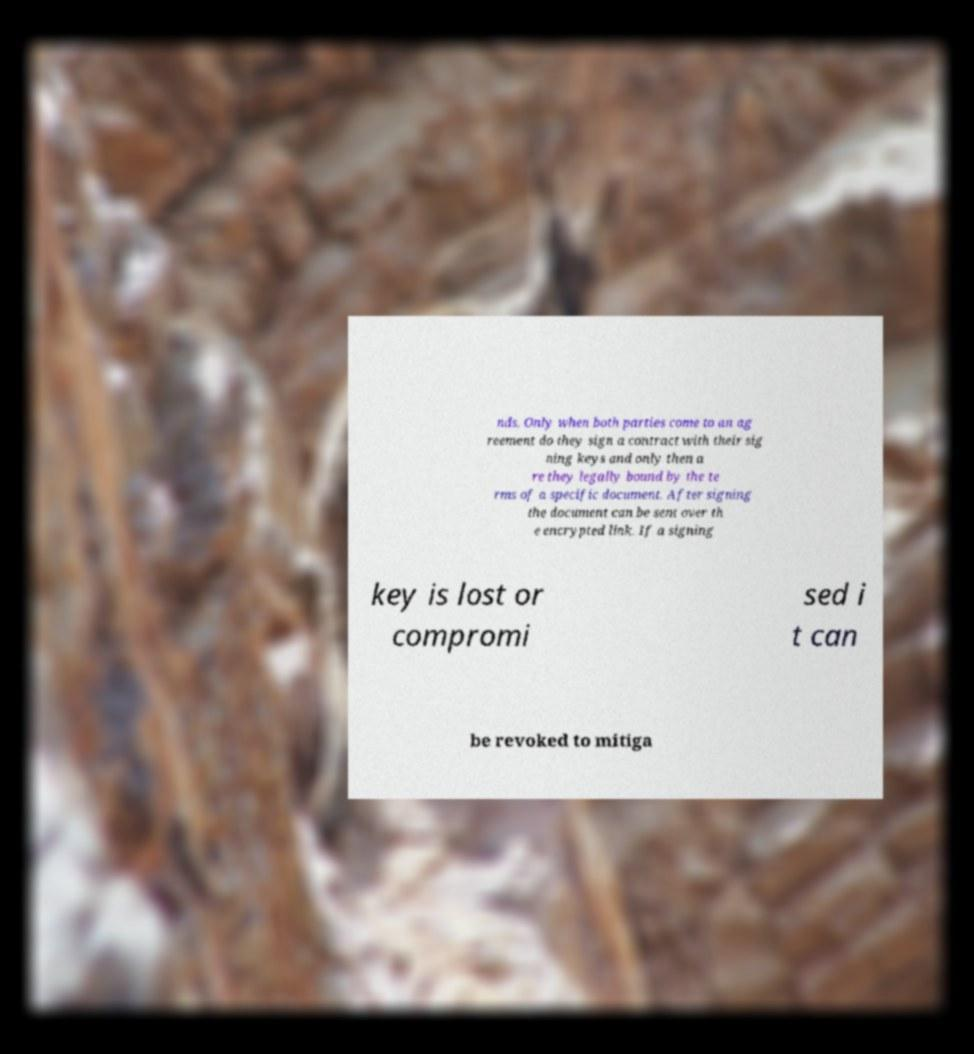What messages or text are displayed in this image? I need them in a readable, typed format. nds. Only when both parties come to an ag reement do they sign a contract with their sig ning keys and only then a re they legally bound by the te rms of a specific document. After signing the document can be sent over th e encrypted link. If a signing key is lost or compromi sed i t can be revoked to mitiga 